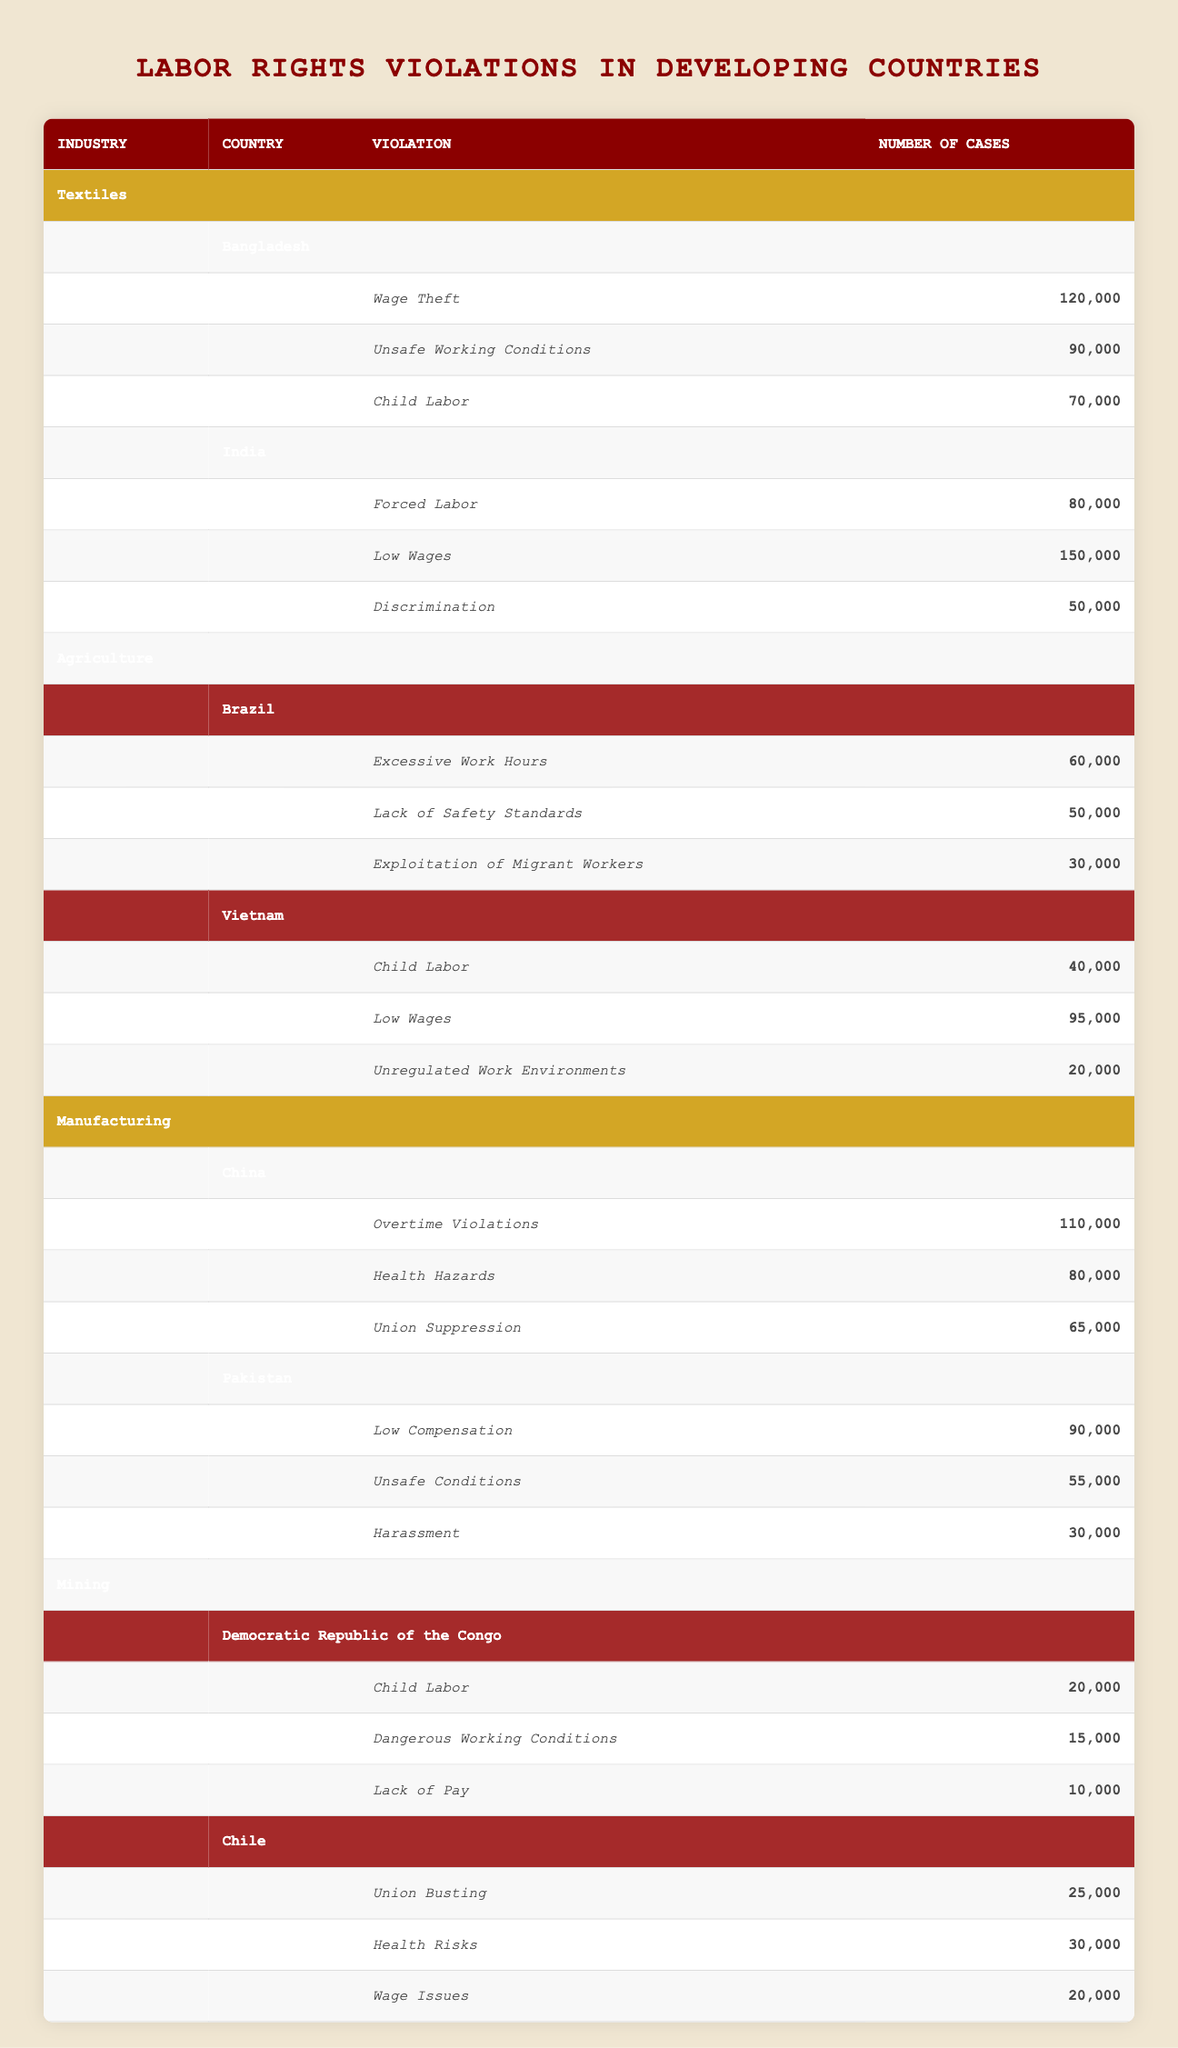What are the total violations reported in the textiles industry in Bangladesh? The total violations in Bangladesh can be calculated by adding the individual violation numbers: Wage Theft (120,000) + Unsafe Working Conditions (90,000) + Child Labor (70,000) = 280,000
Answer: 280,000 Which country has the highest number of low wage violations in agriculture? In agriculture, Vietnam has the highest number of low wage violations with 95,000 cases, while Brazil has 0 for this specific violation. Therefore, Vietnam is the answer.
Answer: Vietnam Is union suppression reported in China? Yes, the table indicates that union suppression is a violation reported in China with 65,000 cases.
Answer: Yes What is the difference in the number of wage theft violations between Bangladesh and India? Bangladesh has 120,000 cases of wage theft, while India has 0. The difference is 120,000 - 0 = 120,000.
Answer: 120,000 Which industry has the most overall violations across all countries listed in the table? To find the industry with the most overall violations, we need to sum the violations for each industry. Textiles has 280,000, Agriculture has 150,000, Manufacturing has 235,000, and Mining has 85,000. Thus, Textiles has the highest total violations.
Answer: Textiles What percentage of violations in the textiles industry are related to unsafe working conditions? The total violations in textiles is 280,000. Unsafe working conditions violations are 90,000. The percentage is (90,000 / 280,000) * 100 = 32.14%.
Answer: 32.14% Is there any report of child labor in the textile industry? In the textiles industry, child labor is reported in Bangladesh with 70,000 cases and not in India. Thus, there is a report of child labor in textiles.
Answer: Yes What are the total number of violations reported in the mining sector in Chile? The total violations in the mining sector in Chile can be calculated by adding the individual violation numbers: Union Busting (25,000) + Health Risks (30,000) + Wage Issues (20,000) = 75,000.
Answer: 75,000 How many cases of low wages are reported in India compared to Vietnam? India reports 150,000 cases of low wages while Vietnam reports 95,000. The difference is 150,000 - 95,000 = 55,000 implying India has more cases.
Answer: India has 55,000 more cases 